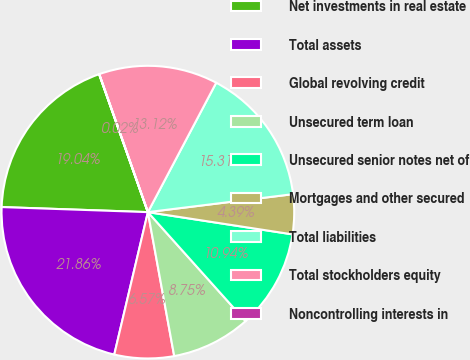<chart> <loc_0><loc_0><loc_500><loc_500><pie_chart><fcel>Net investments in real estate<fcel>Total assets<fcel>Global revolving credit<fcel>Unsecured term loan<fcel>Unsecured senior notes net of<fcel>Mortgages and other secured<fcel>Total liabilities<fcel>Total stockholders equity<fcel>Noncontrolling interests in<nl><fcel>19.04%<fcel>21.86%<fcel>6.57%<fcel>8.75%<fcel>10.94%<fcel>4.39%<fcel>15.31%<fcel>13.12%<fcel>0.02%<nl></chart> 